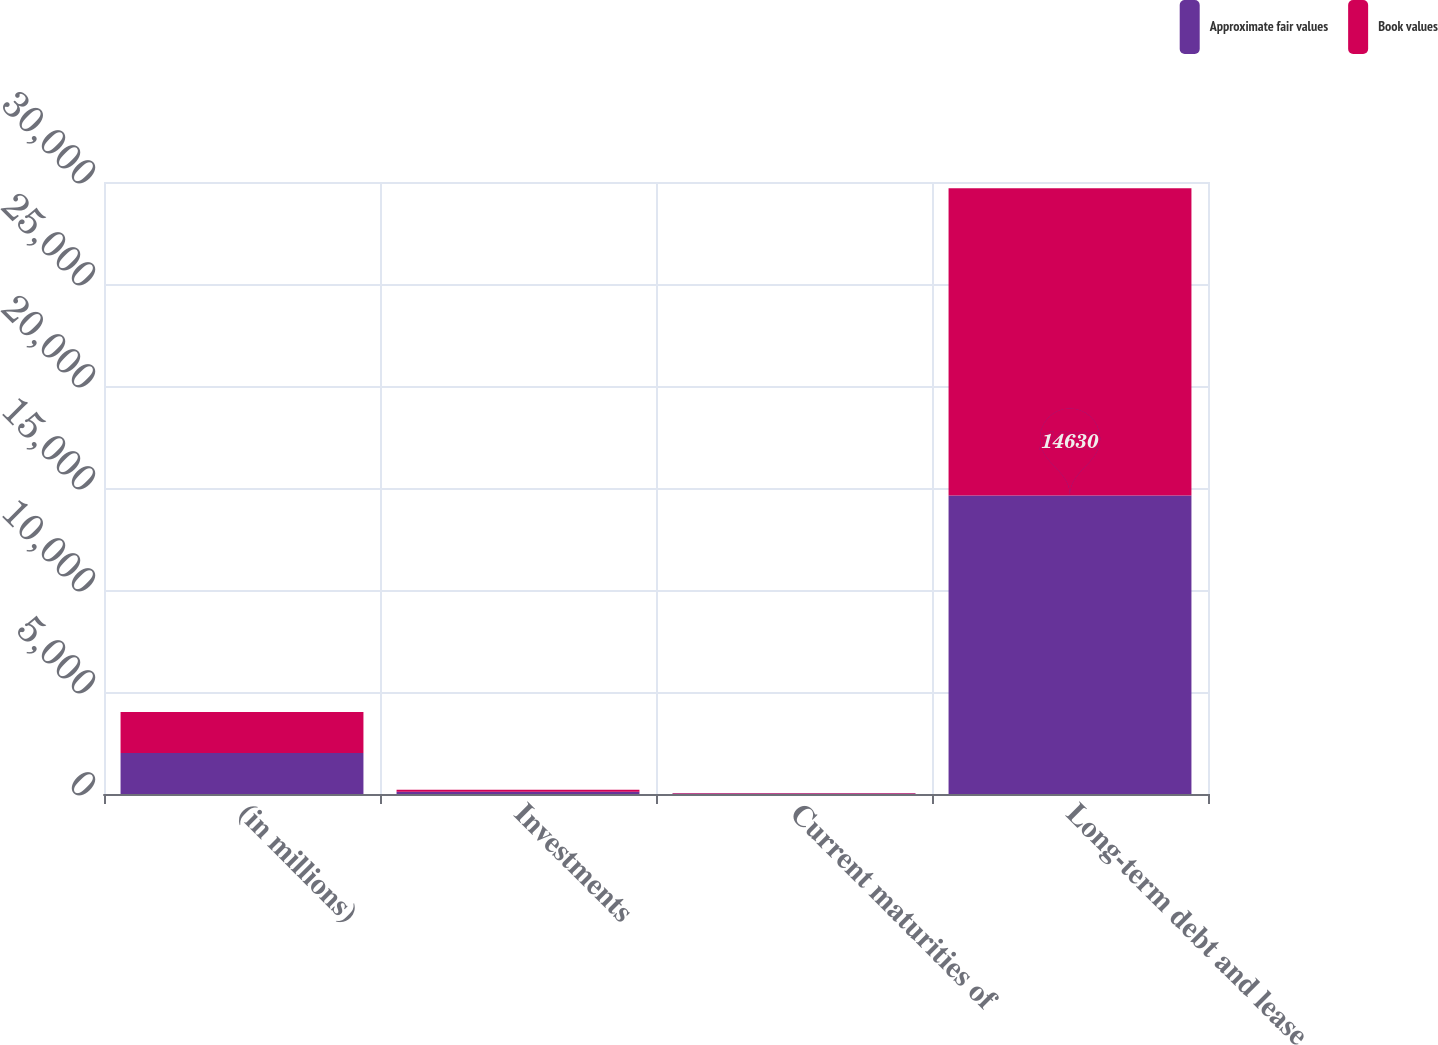<chart> <loc_0><loc_0><loc_500><loc_500><stacked_bar_chart><ecel><fcel>(in millions)<fcel>Investments<fcel>Current maturities of<fcel>Long-term debt and lease<nl><fcel>Approximate fair values<fcel>2012<fcel>107<fcel>22<fcel>14630<nl><fcel>Book values<fcel>2012<fcel>104<fcel>22<fcel>15066<nl></chart> 